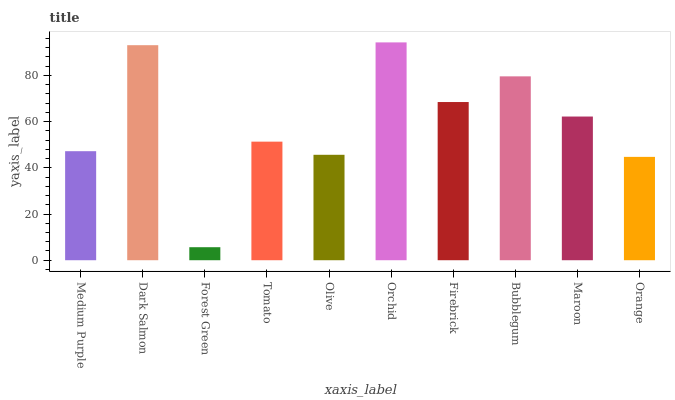Is Forest Green the minimum?
Answer yes or no. Yes. Is Orchid the maximum?
Answer yes or no. Yes. Is Dark Salmon the minimum?
Answer yes or no. No. Is Dark Salmon the maximum?
Answer yes or no. No. Is Dark Salmon greater than Medium Purple?
Answer yes or no. Yes. Is Medium Purple less than Dark Salmon?
Answer yes or no. Yes. Is Medium Purple greater than Dark Salmon?
Answer yes or no. No. Is Dark Salmon less than Medium Purple?
Answer yes or no. No. Is Maroon the high median?
Answer yes or no. Yes. Is Tomato the low median?
Answer yes or no. Yes. Is Medium Purple the high median?
Answer yes or no. No. Is Medium Purple the low median?
Answer yes or no. No. 